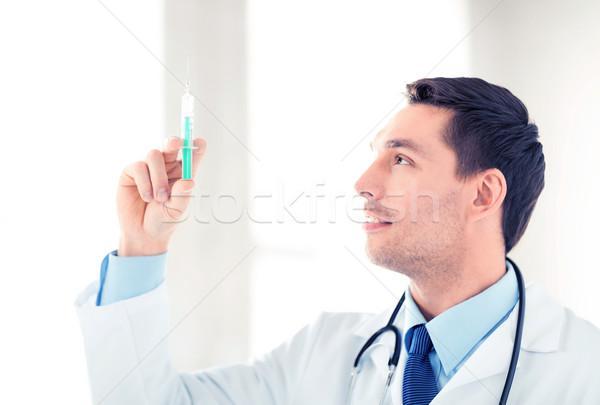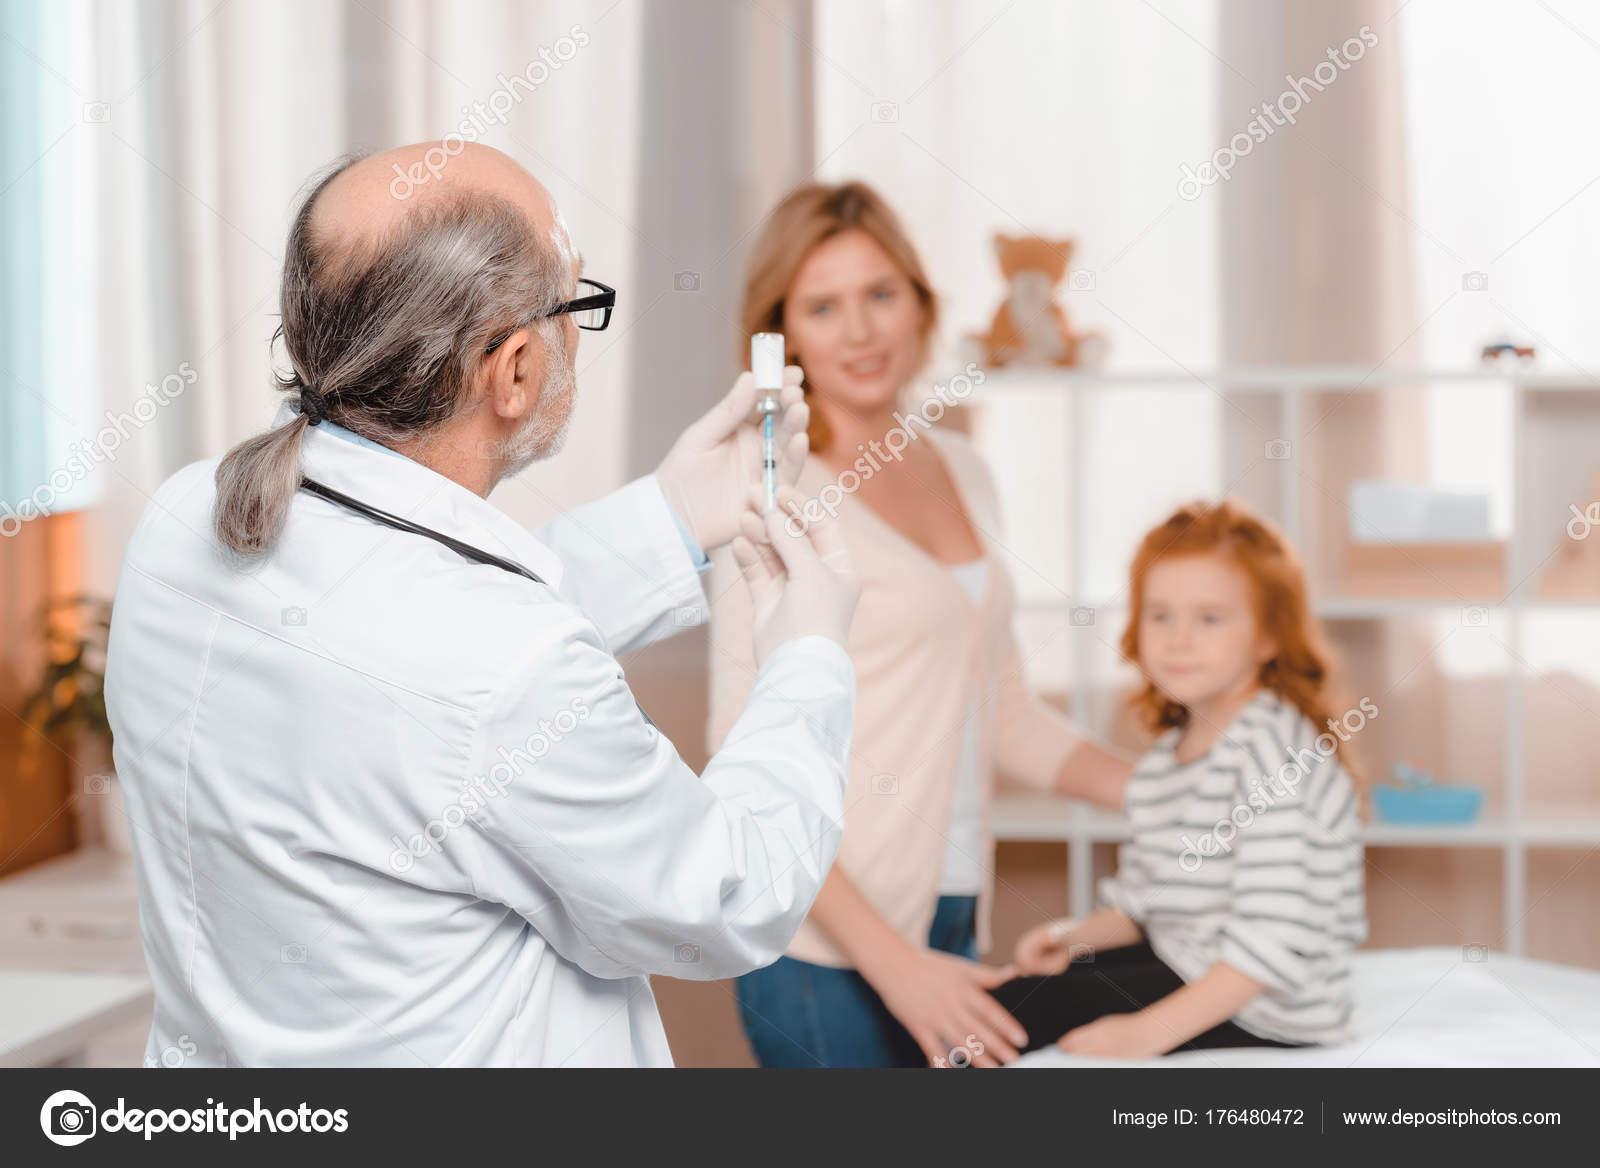The first image is the image on the left, the second image is the image on the right. Assess this claim about the two images: "The left and right image contains the same number of women holding needles.". Correct or not? Answer yes or no. No. The first image is the image on the left, the second image is the image on the right. For the images displayed, is the sentence "Both doctors are women holding needles." factually correct? Answer yes or no. No. 